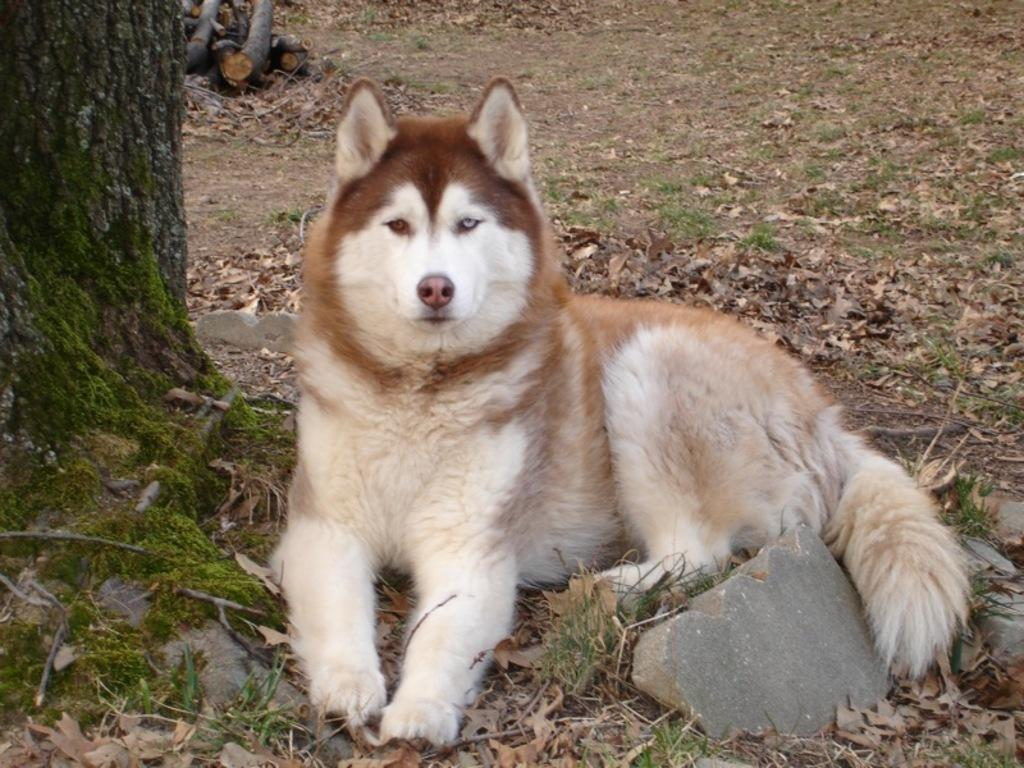What type of animal is in the image? There is a dog in the image. Can you describe the color of the dog? The dog is in cream and brown color. What can be seen in the background of the image? There is a trunk visible in the background of the image. What type of thread is being used by the dog in the image? There is no thread present in the image, and the dog is not using any thread. 